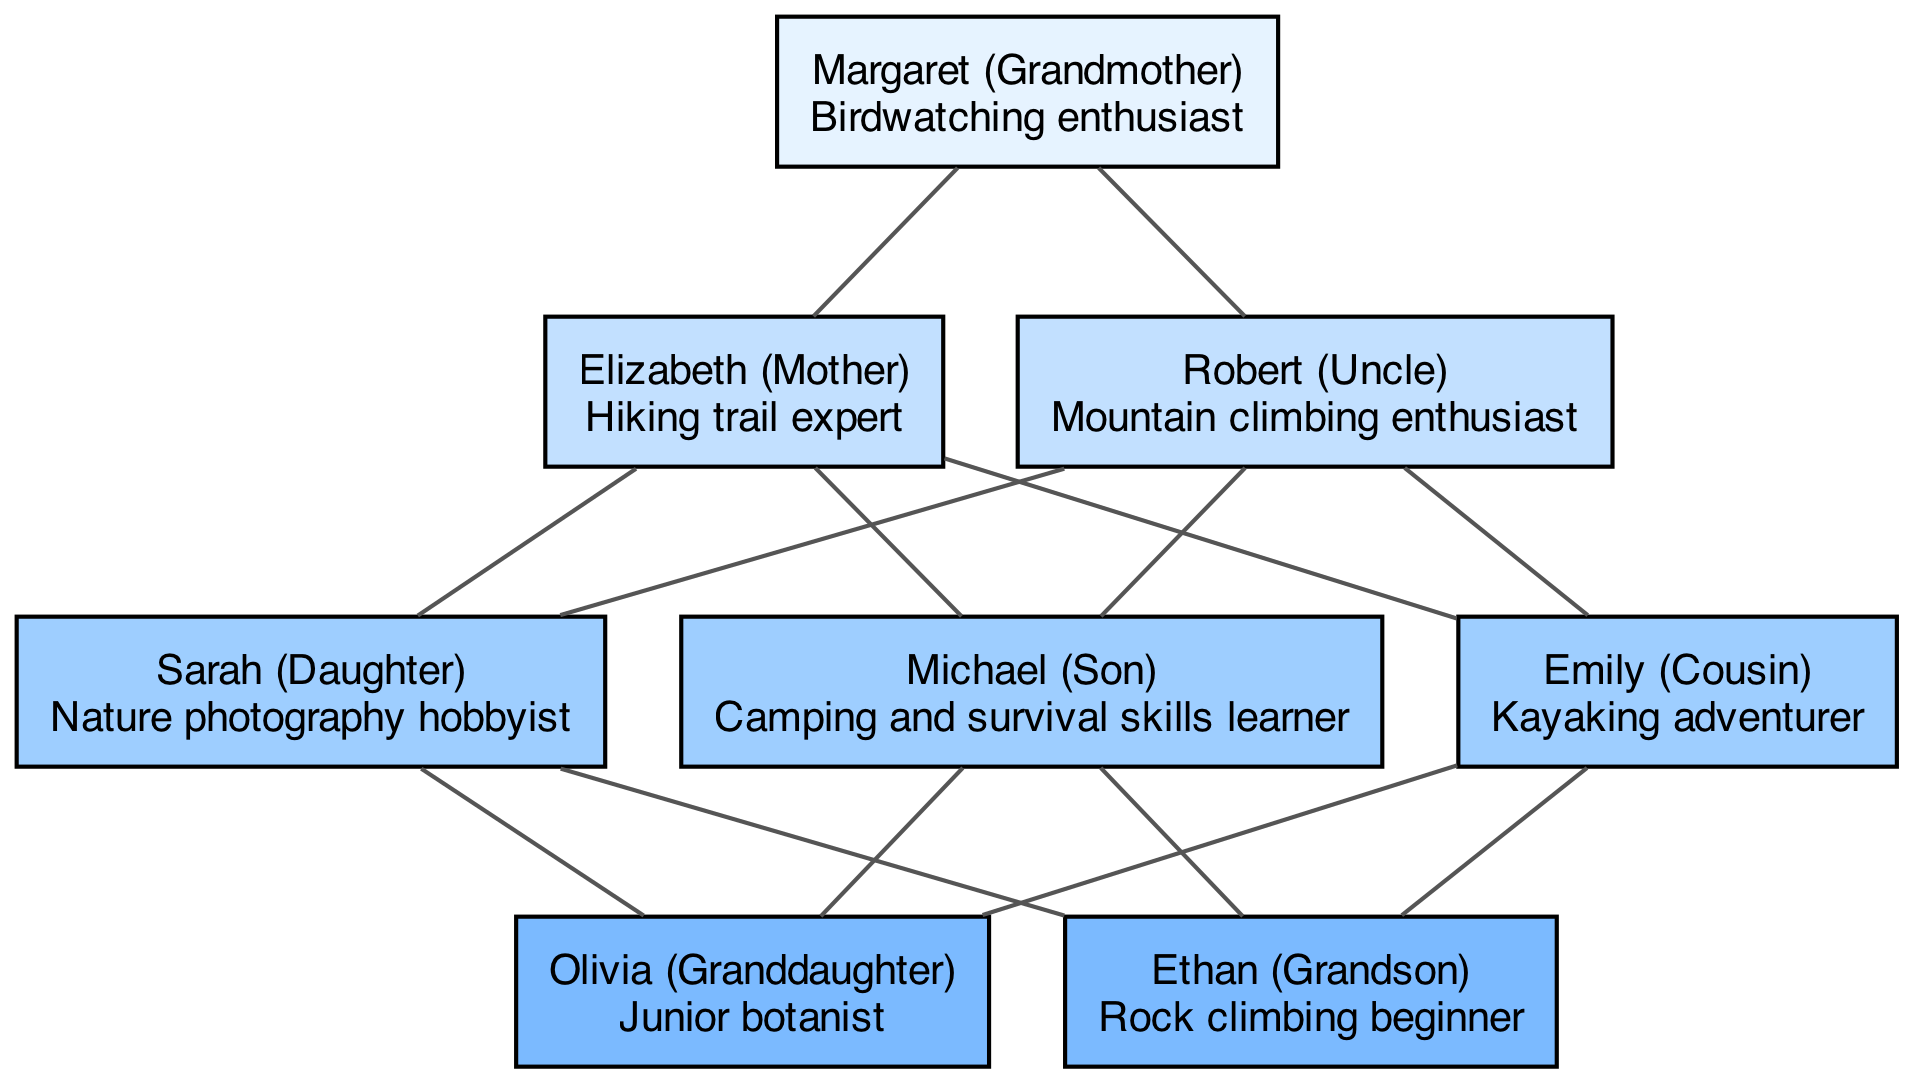What outdoor hobby does Margaret enjoy? The diagram indicates that Margaret is a "Birdwatching enthusiast," which is clearly stated next to her name in the first generation.
Answer: Birdwatching enthusiast Who is the daughter of Elizabeth? According to the diagram, Sarah is listed under Generation 3 as the daughter of Elizabeth in Generation 2, establishing her familial relationship.
Answer: Sarah How many individuals are in Generation 4? The diagram shows that there are two individuals in Generation 4: Olivia and Ethan, which can be directly counted from the nodes listed in that generation.
Answer: 2 What is Robert's preferred outdoor activity? The diagram specifies that Robert, under Generation 2, is a "Mountain climbing enthusiast," which answers the question regarding his preferred outdoor activity.
Answer: Mountain climbing enthusiast Which generation has a junior botanist? Upon inspecting the diagram, Olivia, who is in Generation 4, is specified as a "Junior botanist," thereby identifying the generation associated with this hobby.
Answer: Generation 4 Which activity connects Emily and Robert? The diagram does not provide a direct link between Emily and Robert; they belong to different generations (Emily in Generation 3 and Robert in Generation 2). Therefore, there is no established connection in terms of a shared outdoor activity.
Answer: None How many generations are there in total? By counting the distinct generations labeled in the diagram, we can see that there are a total of four generations represented.
Answer: 4 What is the preferred hobby of the youngest member? The youngest member shown in the diagram is Ethan from Generation 4, and his hobby is specified as "Rock climbing beginner." This is a straightforward assessment based on his positioning as the youngest.
Answer: Rock climbing beginner What link exists between Michael and Sarah? Both Michael and Sarah are in the same generation (Generation 3), as siblings (children of Elizabeth), making this their connection while showcasing their respective nature-based activities.
Answer: Siblings 